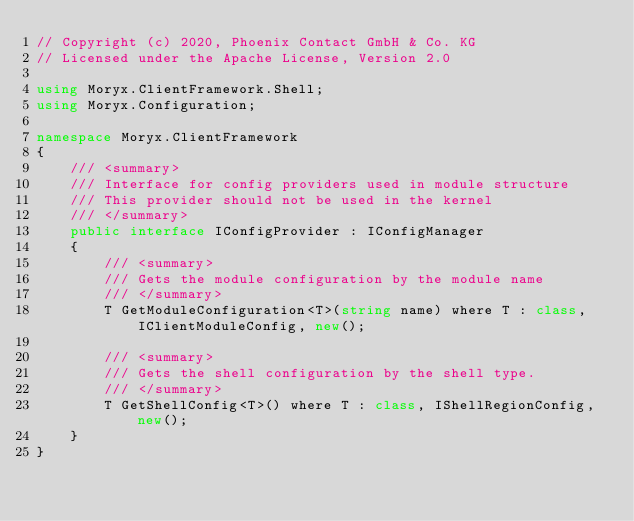Convert code to text. <code><loc_0><loc_0><loc_500><loc_500><_C#_>// Copyright (c) 2020, Phoenix Contact GmbH & Co. KG
// Licensed under the Apache License, Version 2.0

using Moryx.ClientFramework.Shell;
using Moryx.Configuration;

namespace Moryx.ClientFramework
{
    /// <summary>
    /// Interface for config providers used in module structure
    /// This provider should not be used in the kernel
    /// </summary>
    public interface IConfigProvider : IConfigManager
    {
        /// <summary>
        /// Gets the module configuration by the module name
        /// </summary>
        T GetModuleConfiguration<T>(string name) where T : class, IClientModuleConfig, new();

        /// <summary>
        /// Gets the shell configuration by the shell type.
        /// </summary>
        T GetShellConfig<T>() where T : class, IShellRegionConfig, new();
    }
}
</code> 